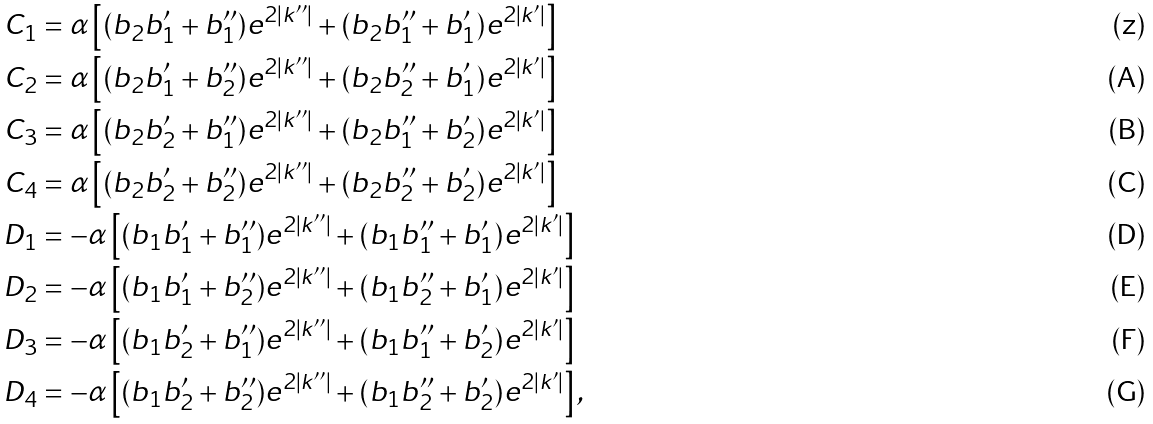Convert formula to latex. <formula><loc_0><loc_0><loc_500><loc_500>C _ { 1 } & = \alpha \left [ ( b _ { 2 } b _ { 1 } ^ { \prime } + b _ { 1 } ^ { \prime \prime } ) e ^ { 2 | k ^ { \prime \prime } | } + ( b _ { 2 } b _ { 1 } ^ { \prime \prime } + b _ { 1 } ^ { \prime } ) e ^ { 2 | k ^ { \prime } | } \right ] \\ C _ { 2 } & = \alpha \left [ ( b _ { 2 } b _ { 1 } ^ { \prime } + b _ { 2 } ^ { \prime \prime } ) e ^ { 2 | k ^ { \prime \prime } | } + ( b _ { 2 } b _ { 2 } ^ { \prime \prime } + b _ { 1 } ^ { \prime } ) e ^ { 2 | k ^ { \prime } | } \right ] \\ C _ { 3 } & = \alpha \left [ ( b _ { 2 } b _ { 2 } ^ { \prime } + b _ { 1 } ^ { \prime \prime } ) e ^ { 2 | k ^ { \prime \prime } | } + ( b _ { 2 } b _ { 1 } ^ { \prime \prime } + b _ { 2 } ^ { \prime } ) e ^ { 2 | k ^ { \prime } | } \right ] \\ C _ { 4 } & = \alpha \left [ ( b _ { 2 } b _ { 2 } ^ { \prime } + b _ { 2 } ^ { \prime \prime } ) e ^ { 2 | k ^ { \prime \prime } | } + ( b _ { 2 } b _ { 2 } ^ { \prime \prime } + b _ { 2 } ^ { \prime } ) e ^ { 2 | k ^ { \prime } | } \right ] \\ D _ { 1 } & = - \alpha \left [ ( b _ { 1 } b _ { 1 } ^ { \prime } + b _ { 1 } ^ { \prime \prime } ) e ^ { 2 | k ^ { \prime \prime } | } + ( b _ { 1 } b _ { 1 } ^ { \prime \prime } + b _ { 1 } ^ { \prime } ) e ^ { 2 | k ^ { \prime } | } \right ] \\ D _ { 2 } & = - \alpha \left [ ( b _ { 1 } b _ { 1 } ^ { \prime } + b _ { 2 } ^ { \prime \prime } ) e ^ { 2 | k ^ { \prime \prime } | } + ( b _ { 1 } b _ { 2 } ^ { \prime \prime } + b _ { 1 } ^ { \prime } ) e ^ { 2 | k ^ { \prime } | } \right ] \\ D _ { 3 } & = - \alpha \left [ ( b _ { 1 } b _ { 2 } ^ { \prime } + b _ { 1 } ^ { \prime \prime } ) e ^ { 2 | k ^ { \prime \prime } | } + ( b _ { 1 } b _ { 1 } ^ { \prime \prime } + b _ { 2 } ^ { \prime } ) e ^ { 2 | k ^ { \prime } | } \right ] \\ D _ { 4 } & = - \alpha \left [ ( b _ { 1 } b _ { 2 } ^ { \prime } + b _ { 2 } ^ { \prime \prime } ) e ^ { 2 | k ^ { \prime \prime } | } + ( b _ { 1 } b _ { 2 } ^ { \prime \prime } + b _ { 2 } ^ { \prime } ) e ^ { 2 | k ^ { \prime } | } \right ] ,</formula> 